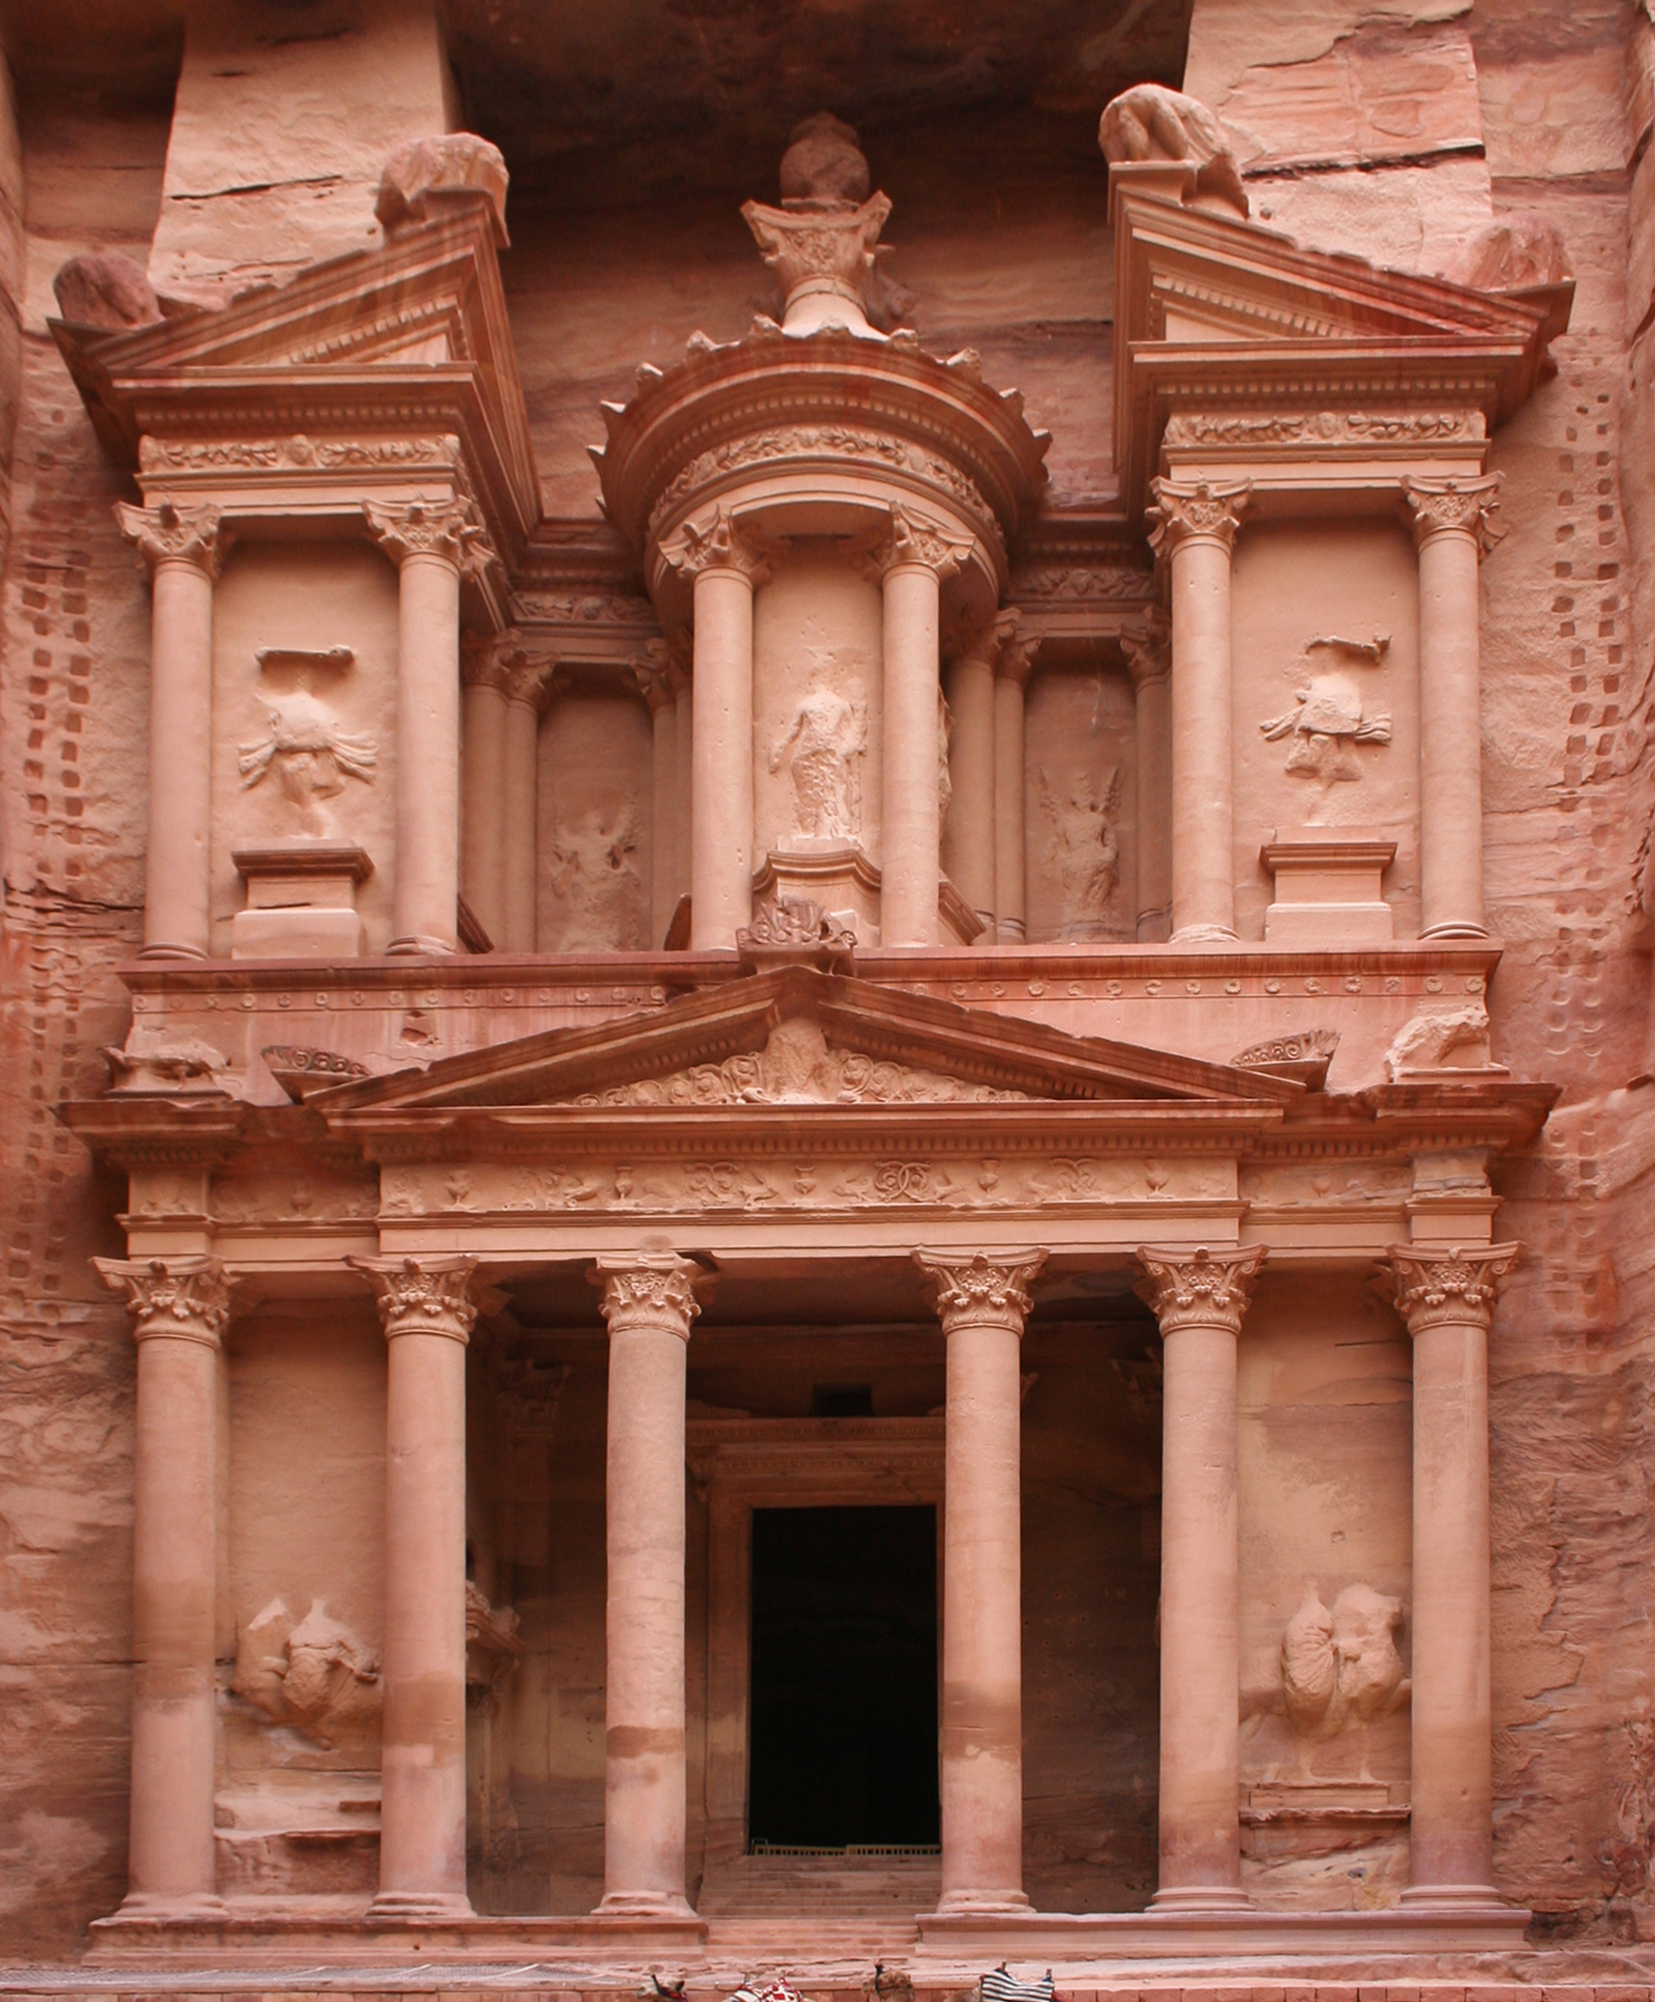Can you describe any visible symbols or decorations on the temple that might tell us more about the culture or beliefs of the people who built it? The façade of the Treasury features several key decorations that provide insight into the cultural and religious beliefs of the Nabataeans. Notably, the temple's upper area displays a funerary urn, which some believe was intended to hold the souls of the deceased, signifying the Nabataeans' beliefs in the afterlife. Additionally, the carvings include mythological figures and patterns that suggest influences from neighboring civilizations, indicating a blend of cultural and religious practices. 